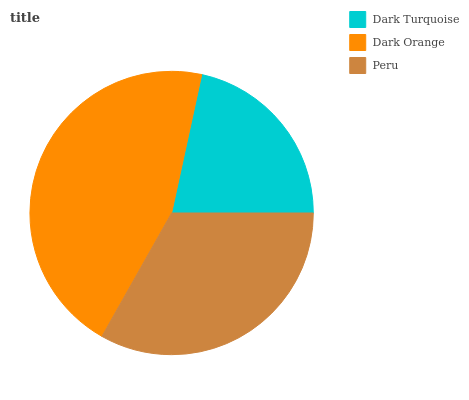Is Dark Turquoise the minimum?
Answer yes or no. Yes. Is Dark Orange the maximum?
Answer yes or no. Yes. Is Peru the minimum?
Answer yes or no. No. Is Peru the maximum?
Answer yes or no. No. Is Dark Orange greater than Peru?
Answer yes or no. Yes. Is Peru less than Dark Orange?
Answer yes or no. Yes. Is Peru greater than Dark Orange?
Answer yes or no. No. Is Dark Orange less than Peru?
Answer yes or no. No. Is Peru the high median?
Answer yes or no. Yes. Is Peru the low median?
Answer yes or no. Yes. Is Dark Orange the high median?
Answer yes or no. No. Is Dark Orange the low median?
Answer yes or no. No. 